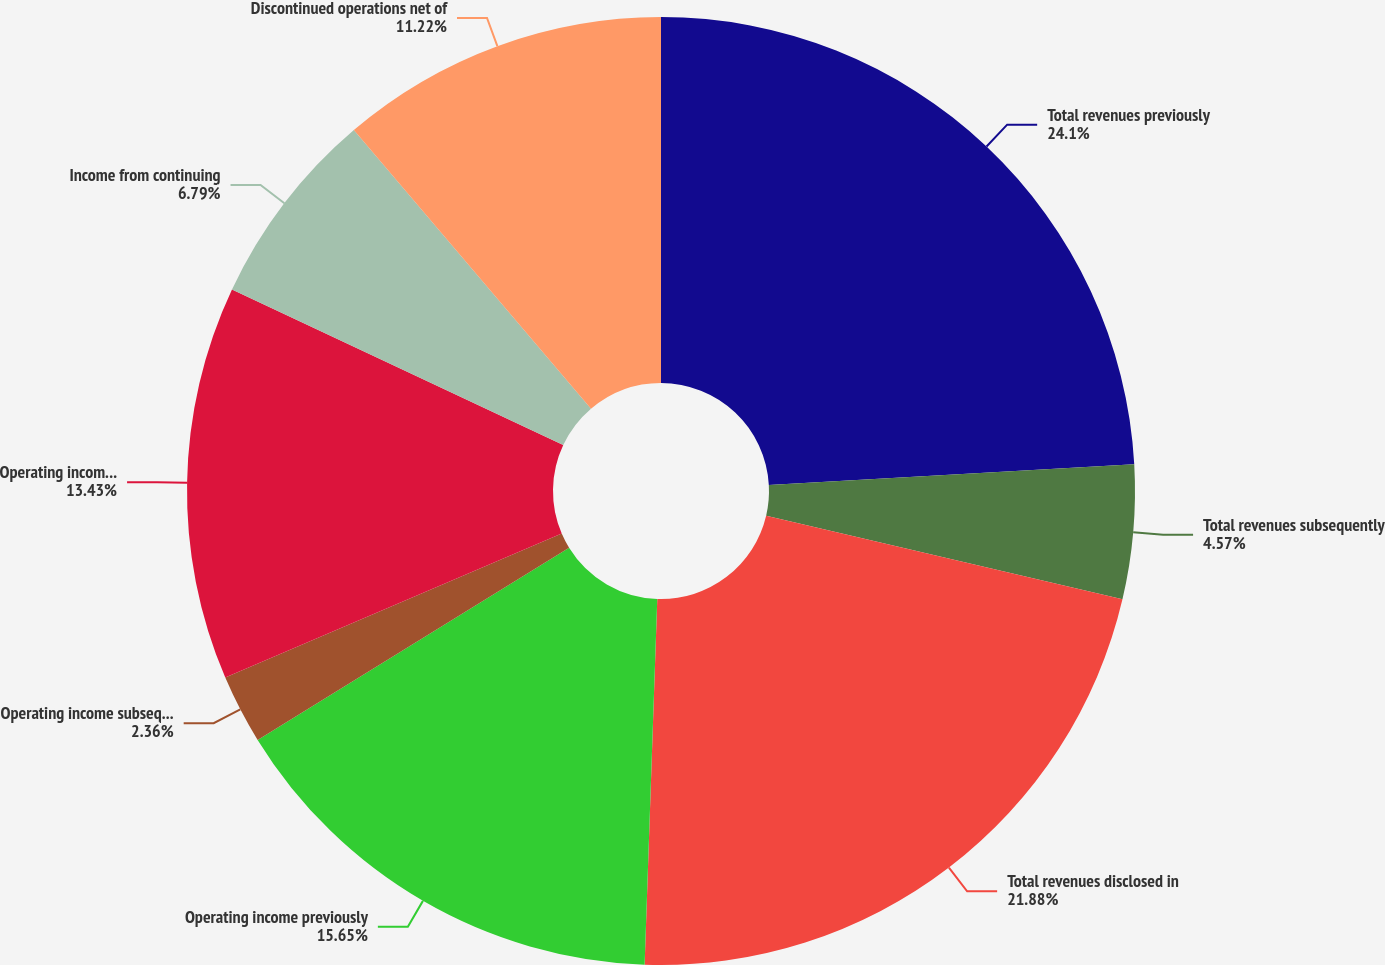<chart> <loc_0><loc_0><loc_500><loc_500><pie_chart><fcel>Total revenues previously<fcel>Total revenues subsequently<fcel>Total revenues disclosed in<fcel>Operating income previously<fcel>Operating income subsequently<fcel>Operating income disclosed in<fcel>Income from continuing<fcel>Discontinued operations net of<nl><fcel>24.1%<fcel>4.57%<fcel>21.88%<fcel>15.65%<fcel>2.36%<fcel>13.43%<fcel>6.79%<fcel>11.22%<nl></chart> 